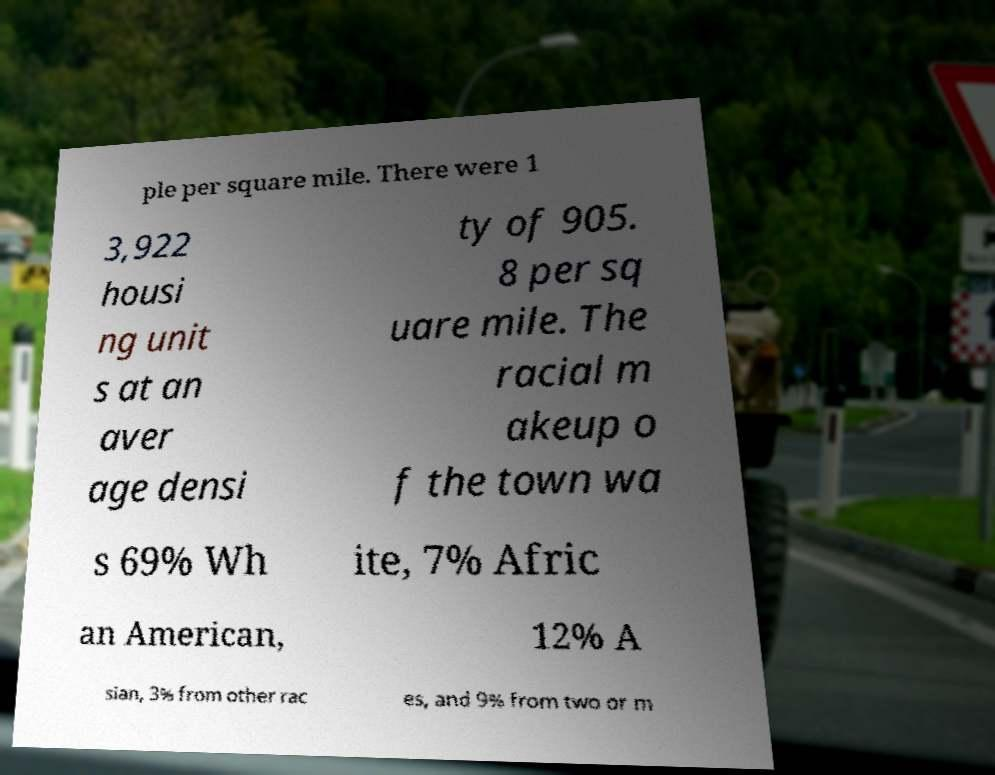What messages or text are displayed in this image? I need them in a readable, typed format. ple per square mile. There were 1 3,922 housi ng unit s at an aver age densi ty of 905. 8 per sq uare mile. The racial m akeup o f the town wa s 69% Wh ite, 7% Afric an American, 12% A sian, 3% from other rac es, and 9% from two or m 